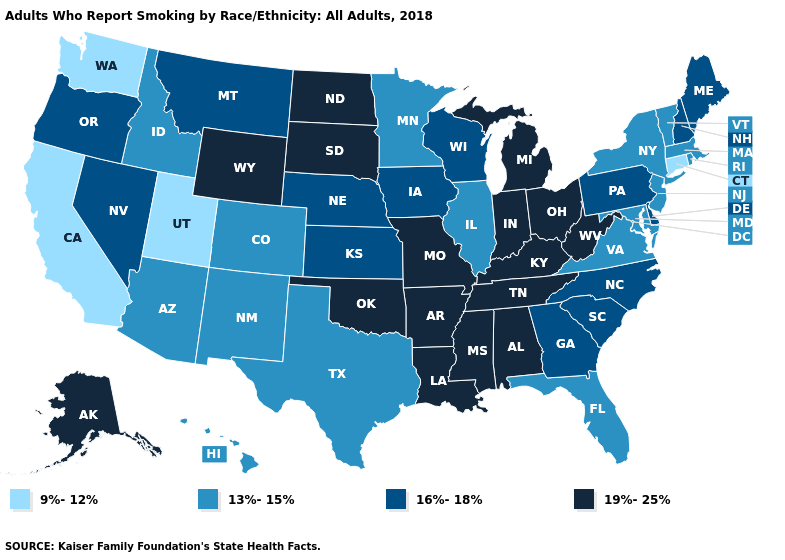Among the states that border Oklahoma , does Arkansas have the highest value?
Concise answer only. Yes. What is the value of Hawaii?
Write a very short answer. 13%-15%. What is the value of Maine?
Be succinct. 16%-18%. What is the value of California?
Concise answer only. 9%-12%. Name the states that have a value in the range 9%-12%?
Be succinct. California, Connecticut, Utah, Washington. Name the states that have a value in the range 19%-25%?
Write a very short answer. Alabama, Alaska, Arkansas, Indiana, Kentucky, Louisiana, Michigan, Mississippi, Missouri, North Dakota, Ohio, Oklahoma, South Dakota, Tennessee, West Virginia, Wyoming. Does Oregon have a lower value than Rhode Island?
Give a very brief answer. No. Does Florida have a lower value than South Dakota?
Be succinct. Yes. Does the first symbol in the legend represent the smallest category?
Short answer required. Yes. Which states have the lowest value in the USA?
Keep it brief. California, Connecticut, Utah, Washington. Name the states that have a value in the range 9%-12%?
Concise answer only. California, Connecticut, Utah, Washington. What is the value of North Carolina?
Concise answer only. 16%-18%. How many symbols are there in the legend?
Concise answer only. 4. Does Rhode Island have a lower value than California?
Quick response, please. No. Which states hav the highest value in the MidWest?
Keep it brief. Indiana, Michigan, Missouri, North Dakota, Ohio, South Dakota. 